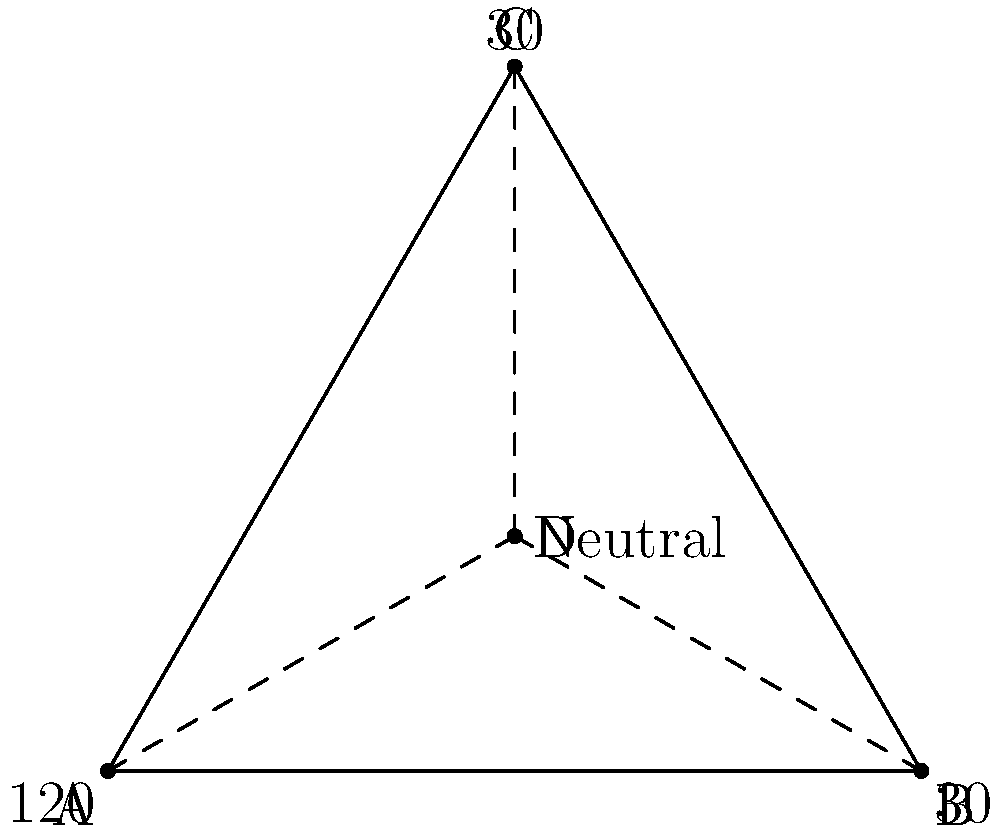In the facial expression triangle ABC, where each vertex represents a distinct emotion (A: Anger, B: Joy, C: Sadness), point D represents a neutral expression. If the angle at vertex A is 120° and the angles at B and C are both 30°, what is the ratio of the distance from D to AC compared to the height of the triangle? To solve this problem, we'll follow these steps:

1. Recognize that triangle ABC is equilateral, as all angles sum to 180° (120° + 30° + 30°).

2. In an equilateral triangle, the height (h) divides the base into two equal parts. Let's call the side length a.

3. The height of an equilateral triangle is given by the formula:
   $$h = \frac{a\sqrt{3}}{2}$$

4. Point D divides the height into two segments. Let's call the distance from D to AC as x.

5. The ratio we're looking for is $\frac{x}{h}$.

6. In an equilateral triangle, the centroid (which is where D is located) divides each median in the ratio 2:1, with the longer segment closer to the vertex.

7. This means that x is 1/3 of the total height h.

8. Therefore, the ratio $\frac{x}{h} = \frac{1}{3}$.

This ratio indicates that the neutral expression (D) is located at 1/3 of the height from the base of the triangle, representing a balanced point between the three extreme emotions.
Answer: 1:3 